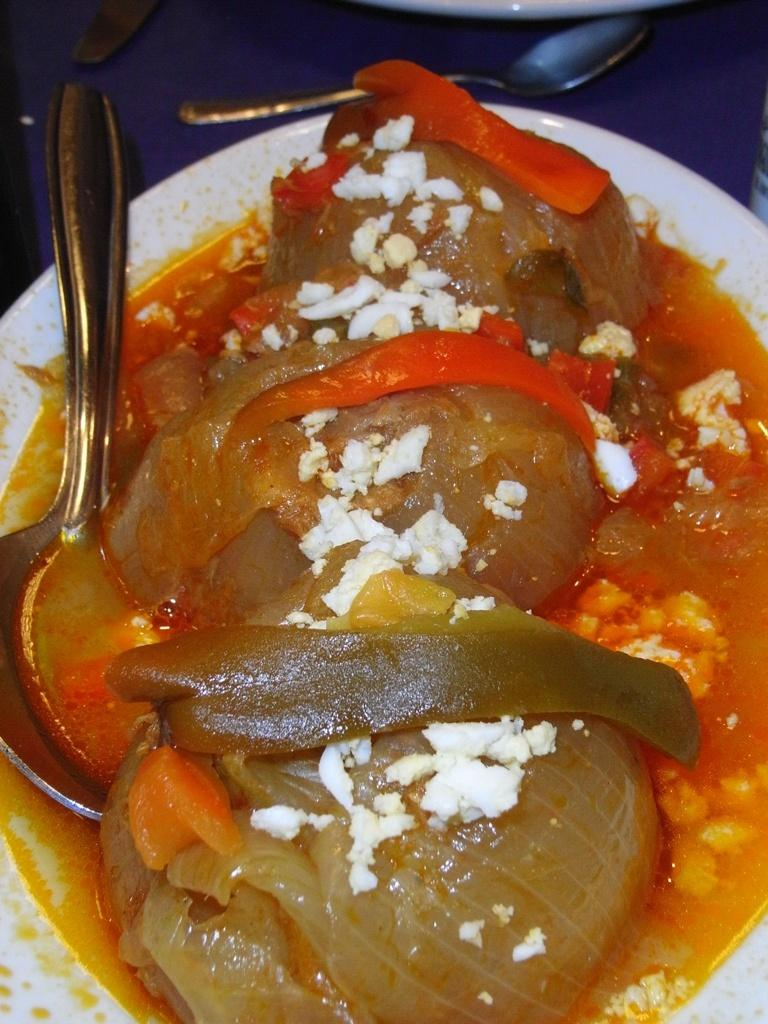What color is the plate in the image? The plate in the image is white. What is on the plate? The plate contains a food item. Can you describe the colors of the food item? The food item has orange, white, red, and green colors. What utensils are visible in the image? There are spoons visible in the image. Is there a hat on the plate in the image? No, there is no hat present on the plate in the image. 